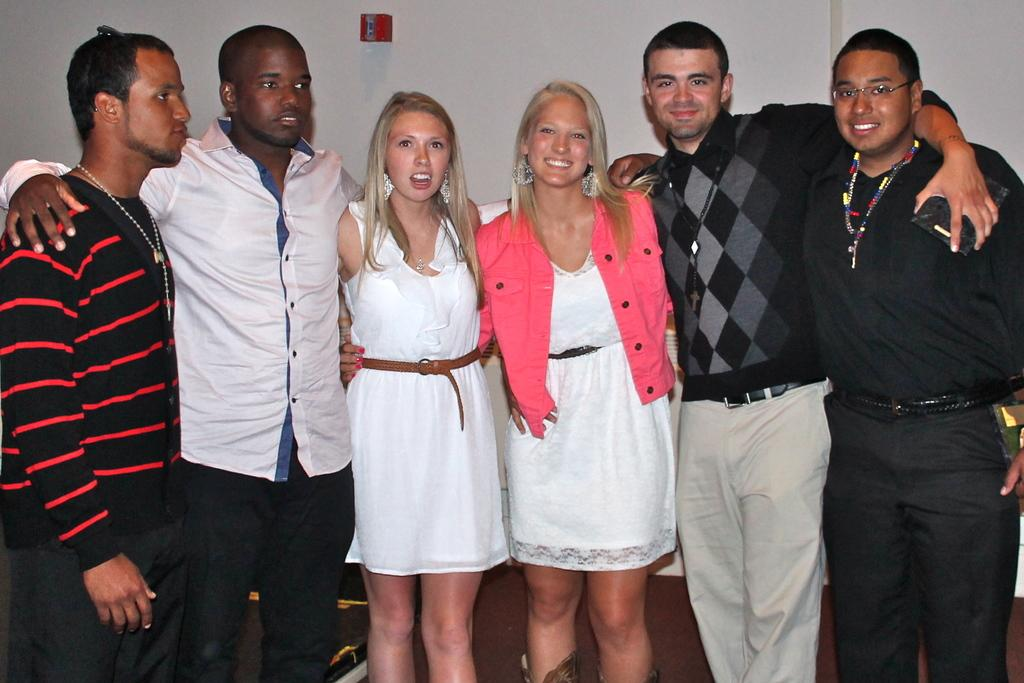How many people are in the image? There is a group of persons in the image. What are the persons in the image doing? The persons are standing and smiling. What can be seen in the background of the image? There is a wall in the background of the image. What is the color of the wall? The wall is white in color. Can you see any brothers in the image? There is no mention of brothers in the image, so we cannot determine if any are present. Is there a hose visible in the image? There is no hose present in the image. 